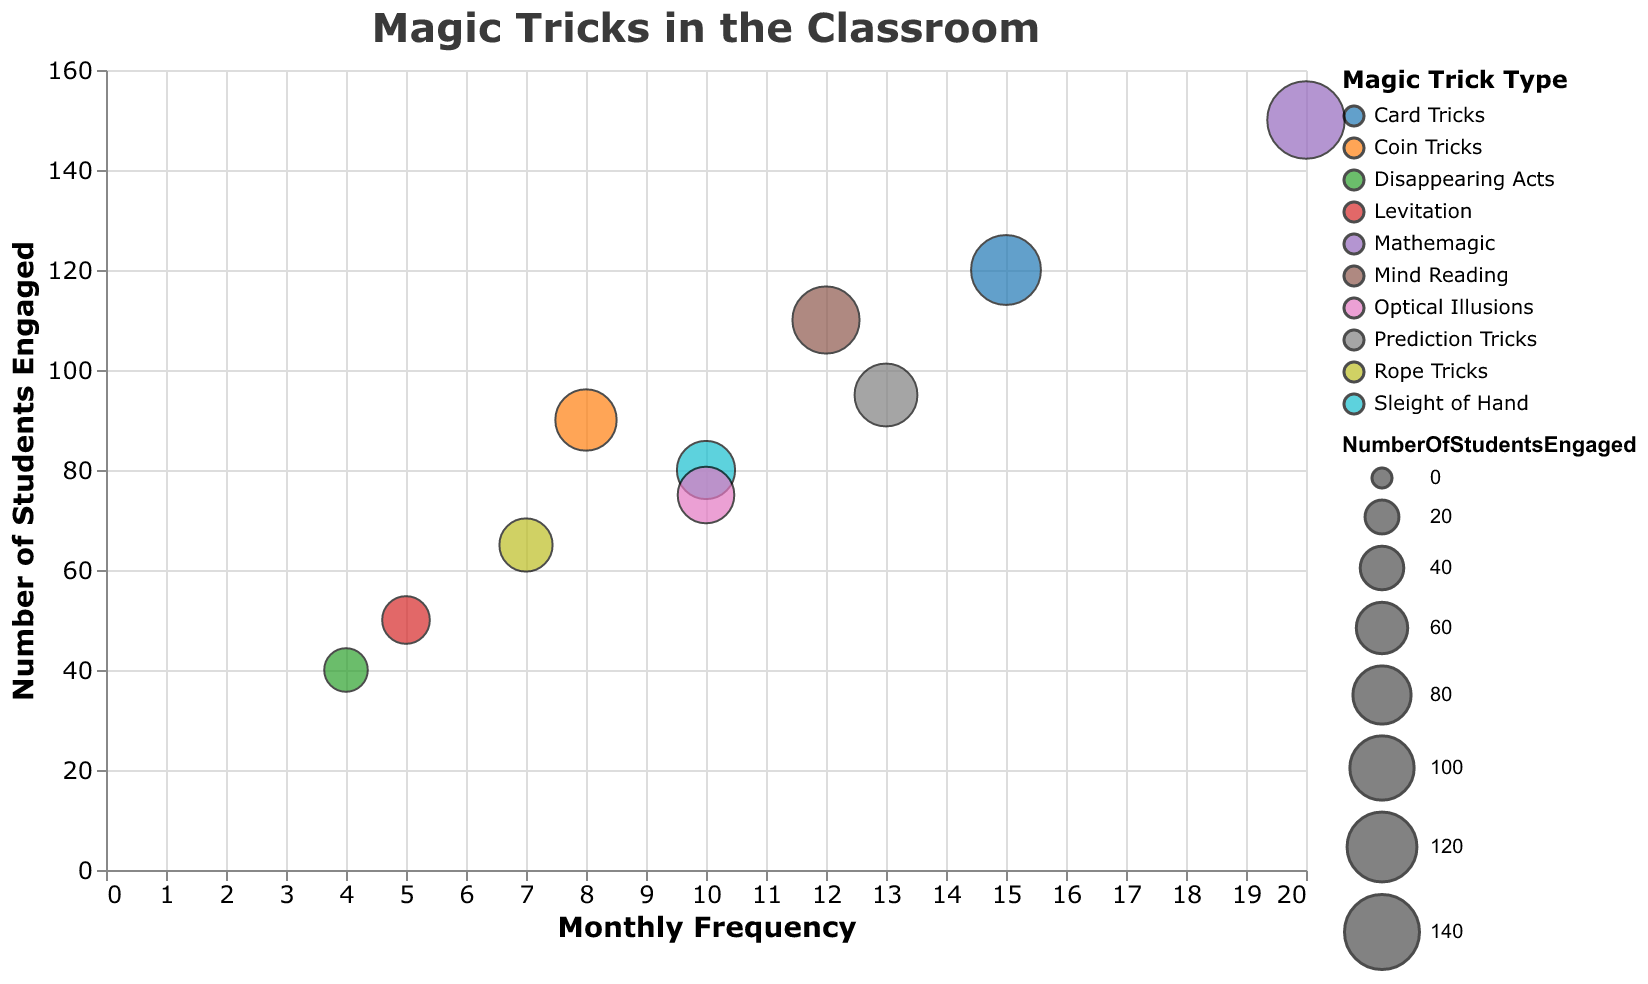What is the title of the chart? The title is displayed at the top of the chart and reads "Magic Tricks in the Classroom".
Answer: Magic Tricks in the Classroom Which magic trick type has the highest monthly frequency? By examining the x-axis, which represents the monthly frequency, the magic trick with the highest frequency has a value of 20. The corresponding magic trick type is "Mathemagic".
Answer: Mathemagic How many students are engaged by "Disappearing Acts"? To find this, locate the bubble representing "Disappearing Acts" and check the value on the y-axis, which represents the number of students engaged. This value is 40.
Answer: 40 Which magic trick type engages the most students? Look for the bubble with the highest y-axis value. "Mathemagic" engages the most students with a value of 150.
Answer: Mathemagic What is the average monthly frequency of "Card Tricks" and "Mind Reading"? "Card Tricks" has a frequency of 15, and "Mind Reading" has a frequency of 12. The average is calculated as (15 + 12) / 2 = 13.5.
Answer: 13.5 Compare the number of students engaged by "Optical Illusions" and "Sleight of Hand". Which engages more? "Optical Illusions" engages 75 students, while "Sleight of Hand" engages 80 students. Therefore, "Sleight of Hand" engages more.
Answer: Sleight of Hand What is the difference in student engagement between the most frequently used and least frequently used magic tricks? The most frequently used trick is "Mathemagic" with 150 students, and the least frequently used is "Disappearing Acts" with 40 students. The difference is 150 - 40 = 110.
Answer: 110 Which magic trick types have a monthly frequency of exactly 10? Find bubbles aligned with the frequency value of 10 on the x-axis. These trick types are "Sleight of Hand" and "Optical Illusions".
Answer: Sleight of Hand and Optical Illusions How many bubbles are displayed in the chart? Counting the individual bubbles representing each magic trick type results in a total of 10 bubbles.
Answer: 10 What is the median number of students engaged across all the magic tricks? Arrange the student engagement values (40, 50, 65, 75, 80, 90, 95, 110, 120, 150). The median is the average of the 5th and 6th values: (80 + 90) / 2 = 85.
Answer: 85 